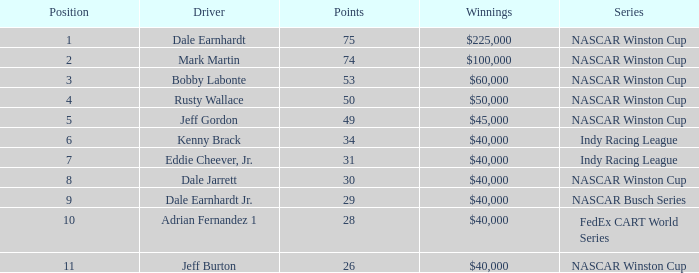What was the sum of kenny brack's victory? $40,000. 